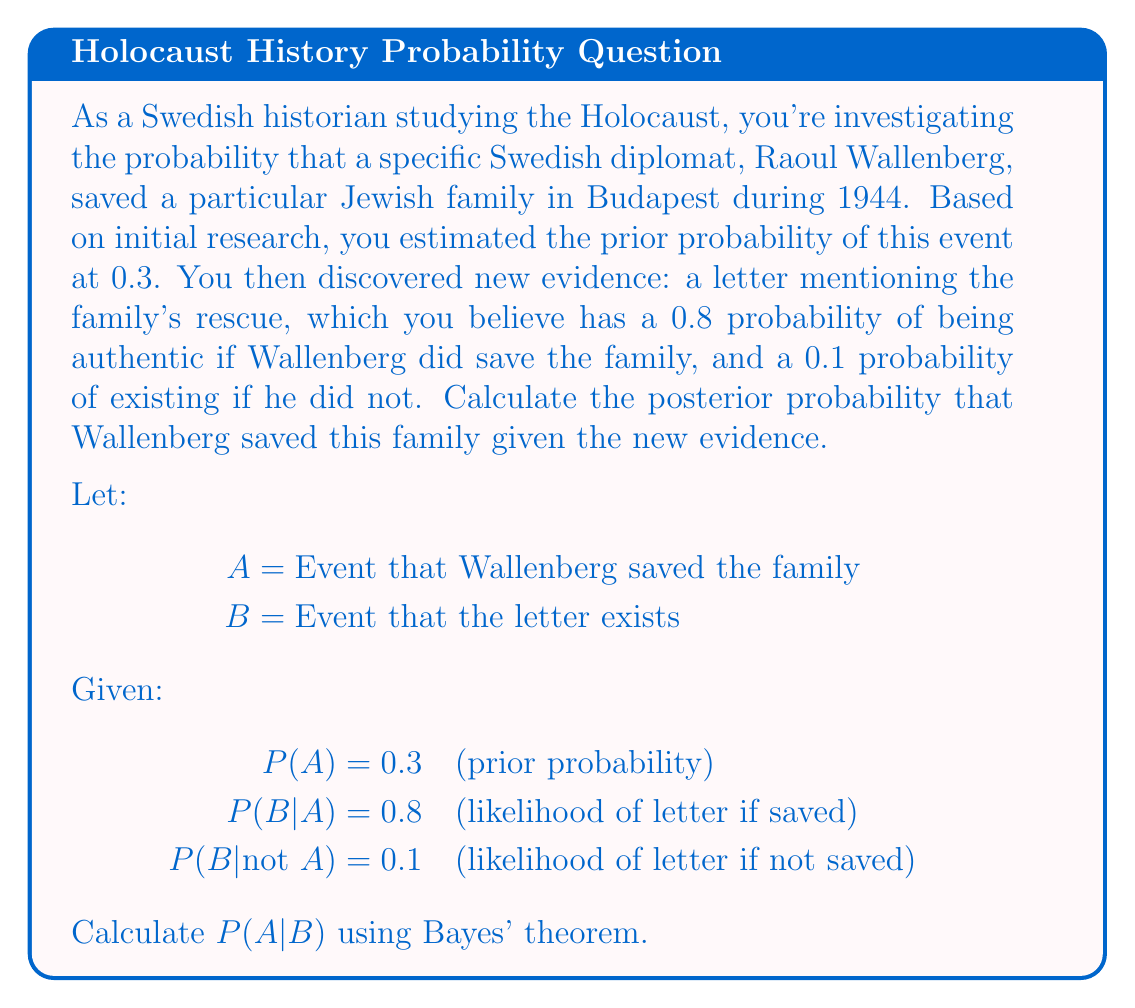Can you answer this question? To solve this problem, we'll use Bayes' theorem:

$$ P(A|B) = \frac{P(B|A) \cdot P(A)}{P(B)} $$

1. We're given P(A) = 0.3, P(B|A) = 0.8, and P(B|not A) = 0.1

2. We need to calculate P(B) using the law of total probability:
   $$ P(B) = P(B|A) \cdot P(A) + P(B|\text{not }A) \cdot P(\text{not }A) $$
   $$ P(B) = 0.8 \cdot 0.3 + 0.1 \cdot (1 - 0.3) $$
   $$ P(B) = 0.24 + 0.07 = 0.31 $$

3. Now we can apply Bayes' theorem:
   $$ P(A|B) = \frac{0.8 \cdot 0.3}{0.31} $$
   $$ P(A|B) = \frac{0.24}{0.31} \approx 0.7742 $$

4. Convert to a percentage:
   $$ 0.7742 \cdot 100\% \approx 77.42\% $$

Thus, given the new evidence of the letter, the posterior probability that Wallenberg saved this family is approximately 77.42%.
Answer: 77.42% 